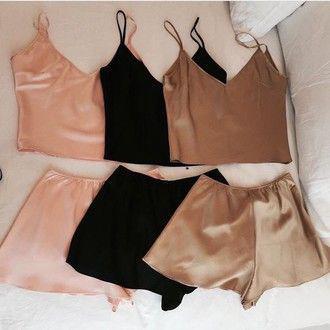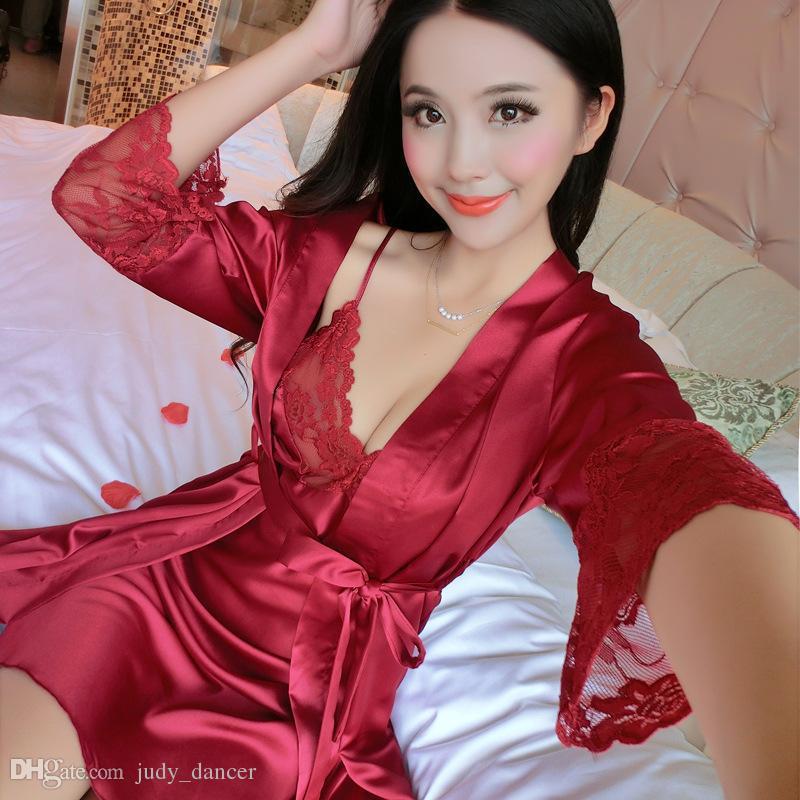The first image is the image on the left, the second image is the image on the right. For the images displayed, is the sentence "A pajama set worn by a woman in one image is made with a silky fabric with button-down long sleeve shirt, with cuffs on both the shirt sleeves and pant legs." factually correct? Answer yes or no. No. The first image is the image on the left, the second image is the image on the right. Given the left and right images, does the statement "One image shows a model wearing a sleeved open-front top over a lace-trimmed garment with spaghetti straps." hold true? Answer yes or no. Yes. 